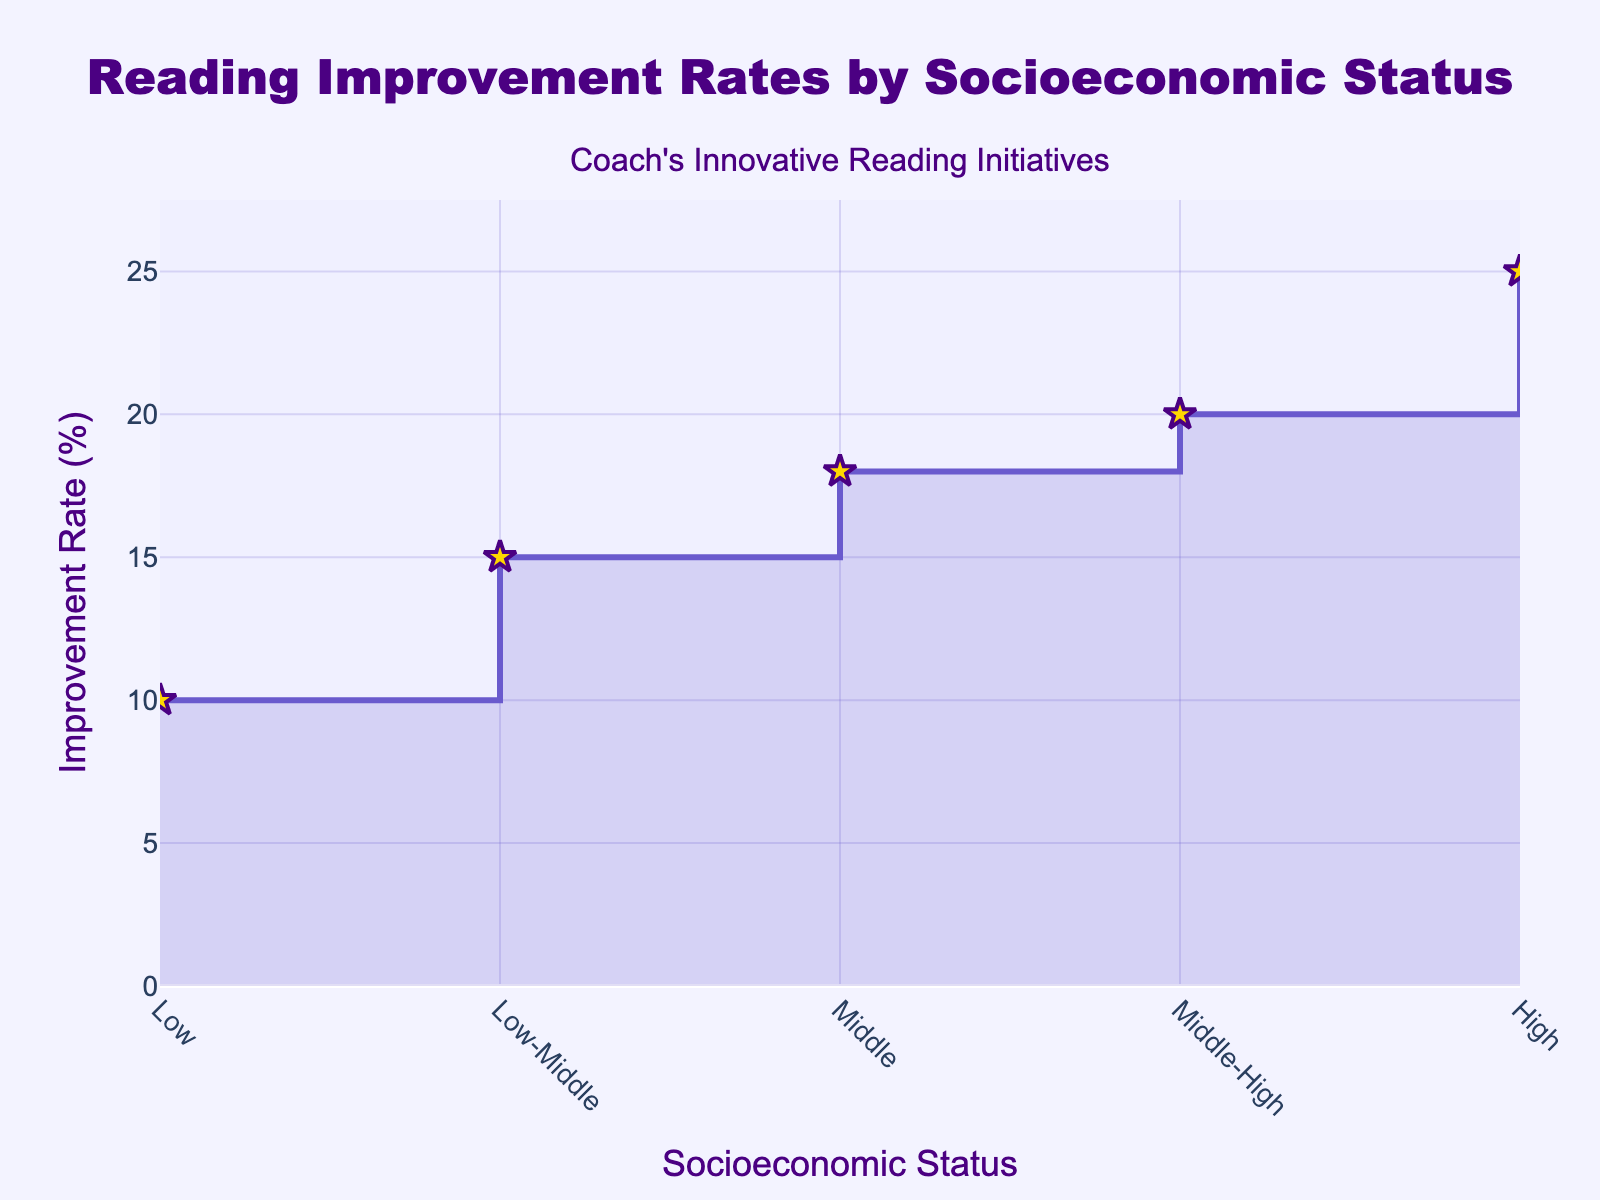What is the title of the graph? The title is located at the top center of the graph. It reads "Reading Improvement Rates by Socioeconomic Status".
Answer: Reading Improvement Rates by Socioeconomic Status Which socioeconomic group has the highest reading improvement rate? The y-axis represents the improvement rate, and the highest point corresponds to the "High" socioeconomic status on the x-axis.
Answer: High What is the reading improvement rate for the Low socioeconomic group? By finding the 'Low' socioeconomic group on the x-axis and tracing it vertically to the y-axis, we see the improvement rate is 10%.
Answer: 10% How does the reading improvement rate of the Low-Middle group compare to the Middle-High group? The reading improvement rate for the Low-Middle group is 15%, and for the Middle-High group, it is 20%. Comparing these, the Middle-High group has a 5% higher improvement rate.
Answer: 5% What is the difference in the improvement rates between the Middle and High socioeconomic groups? The Middle group has an 18% improvement rate, while the High group has a 25% improvement rate. The difference is 25% - 18% = 7%.
Answer: 7% What trend can be observed from the graph regarding socioeconomic status and reading improvement rates? The graph shows a stair-step increase from Low to High socioeconomic status, indicating that higher socioeconomic statuses are associated with higher reading improvement rates.
Answer: Higher socioeconomic statuses are associated with higher reading improvement rates Calculate the average improvement rate for the socioeconomic groups shown. The improvement rates are: 10%, 15%, 18%, 20%, 25%. Sum these: 10 + 15 + 18 + 20 + 25 = 88. Divide by the number of groups: 88 / 5 = 17.6%.
Answer: 17.6% In which socioeconomic status groups does the improvement rate exceed 15%? Groups with rates greater than 15% are Middle (18%), Middle-High (20%), and High (25%).
Answer: Middle, Middle-High, High What is the overall range of improvement rates shown in the graph? The lowest rate is for the Low socioeconomic group at 10%, and the highest is for the High group at 25%. The range is 25% - 10% = 15%.
Answer: 15% What does the annotation on the graph refer to? The annotation reads "Coach's Innovative Reading Initiatives" and is located above the title, indicating that the reading improvement rates are presumably influenced by these initiatives.
Answer: Coach's Innovative Reading Initiatives 